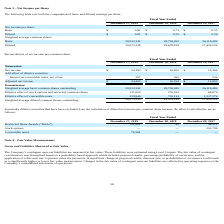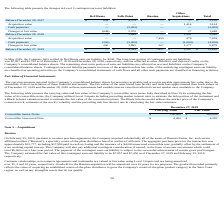According to Chefs Wharehouse's financial document, What information does the table present? the changes in Level 3 contingent earn-out liabilities. The document states: "The following table presents the changes in Level 3 contingent earn-out liabilities:..." Also, What is the total Balance in December 29, 2017? According to the financial document, $5,228. The relevant text states: "Balance December 29, 2017 $ 649 $ 4,579 $ — $ — $ 5,228..." Also, What is the amount the Company used in May 2019 to settle its Del Monte earn-out liability? According to the financial document, $200. The relevant text states: "fully settled its Del Monte earn-out liability for $200. The long-term portion of contingent earn-out liabilities was $7,957 and $2,792 as of December 27,..." Also, can you calculate: What is the change in total balance between fiscal years 2017 and 2018? Based on the calculation: 5,228-5,090, the result is 138. This is based on the information: "Balance December 28, 2018 — 3,649 — 1,441 5,090 Balance December 29, 2017 $ 649 $ 4,579 $ — $ — $ 5,228..." The key data points involved are: 5,090, 5,228. Also, can you calculate: What is the average long-term portion of contingent earn-out liabilities for 2018 and 2019? To answer this question, I need to perform calculations using the financial data. The calculation is: (7,957+ 2,792)/2, which equals 5374.5. This is based on the information: "f contingent earn-out liabilities was $7,957 and $2,792 as of December 27, 2019 and December 28, 2018, respectively, and are reflected as other liabilities Balance December 27, 2019 $ — $ 4,544 $ 7,95..." The key data points involved are: 2,792, 7,957. Also, can you calculate: What is the change in long-term portion of contingent earn-out liabilities for 2018 and 2019? Based on the calculation: 7,957-2,792, the result is 5165. This is based on the information: "f contingent earn-out liabilities was $7,957 and $2,792 as of December 27, 2019 and December 28, 2018, respectively, and are reflected as other liabilities Balance December 27, 2019 $ — $ 4,544 $ 7,95..." The key data points involved are: 2,792, 7,957. 